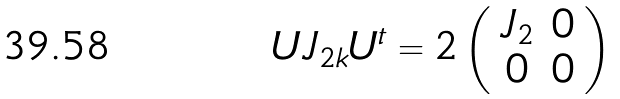<formula> <loc_0><loc_0><loc_500><loc_500>U J _ { 2 k } U ^ { t } = 2 \left ( \begin{array} { c c } J _ { 2 } & 0 \\ 0 & 0 \end{array} \right )</formula> 